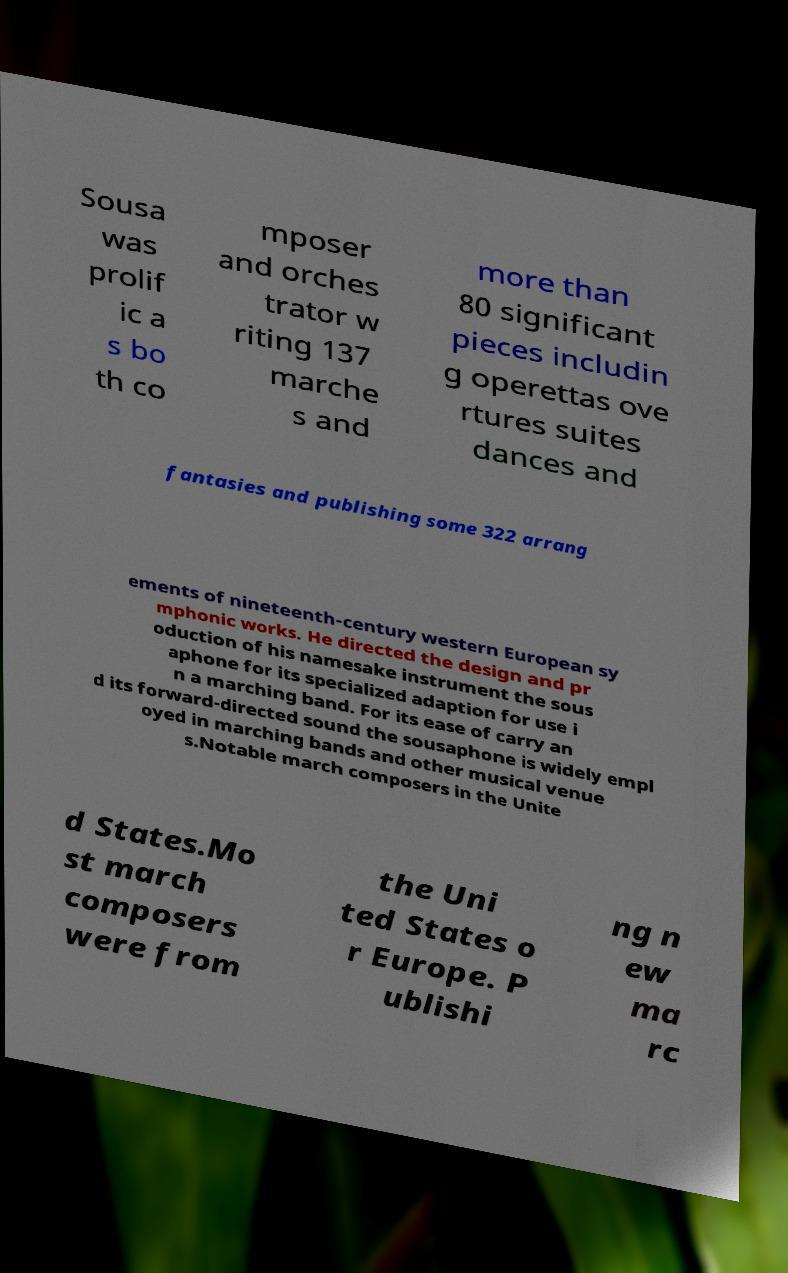Can you read and provide the text displayed in the image?This photo seems to have some interesting text. Can you extract and type it out for me? Sousa was prolif ic a s bo th co mposer and orches trator w riting 137 marche s and more than 80 significant pieces includin g operettas ove rtures suites dances and fantasies and publishing some 322 arrang ements of nineteenth-century western European sy mphonic works. He directed the design and pr oduction of his namesake instrument the sous aphone for its specialized adaption for use i n a marching band. For its ease of carry an d its forward-directed sound the sousaphone is widely empl oyed in marching bands and other musical venue s.Notable march composers in the Unite d States.Mo st march composers were from the Uni ted States o r Europe. P ublishi ng n ew ma rc 